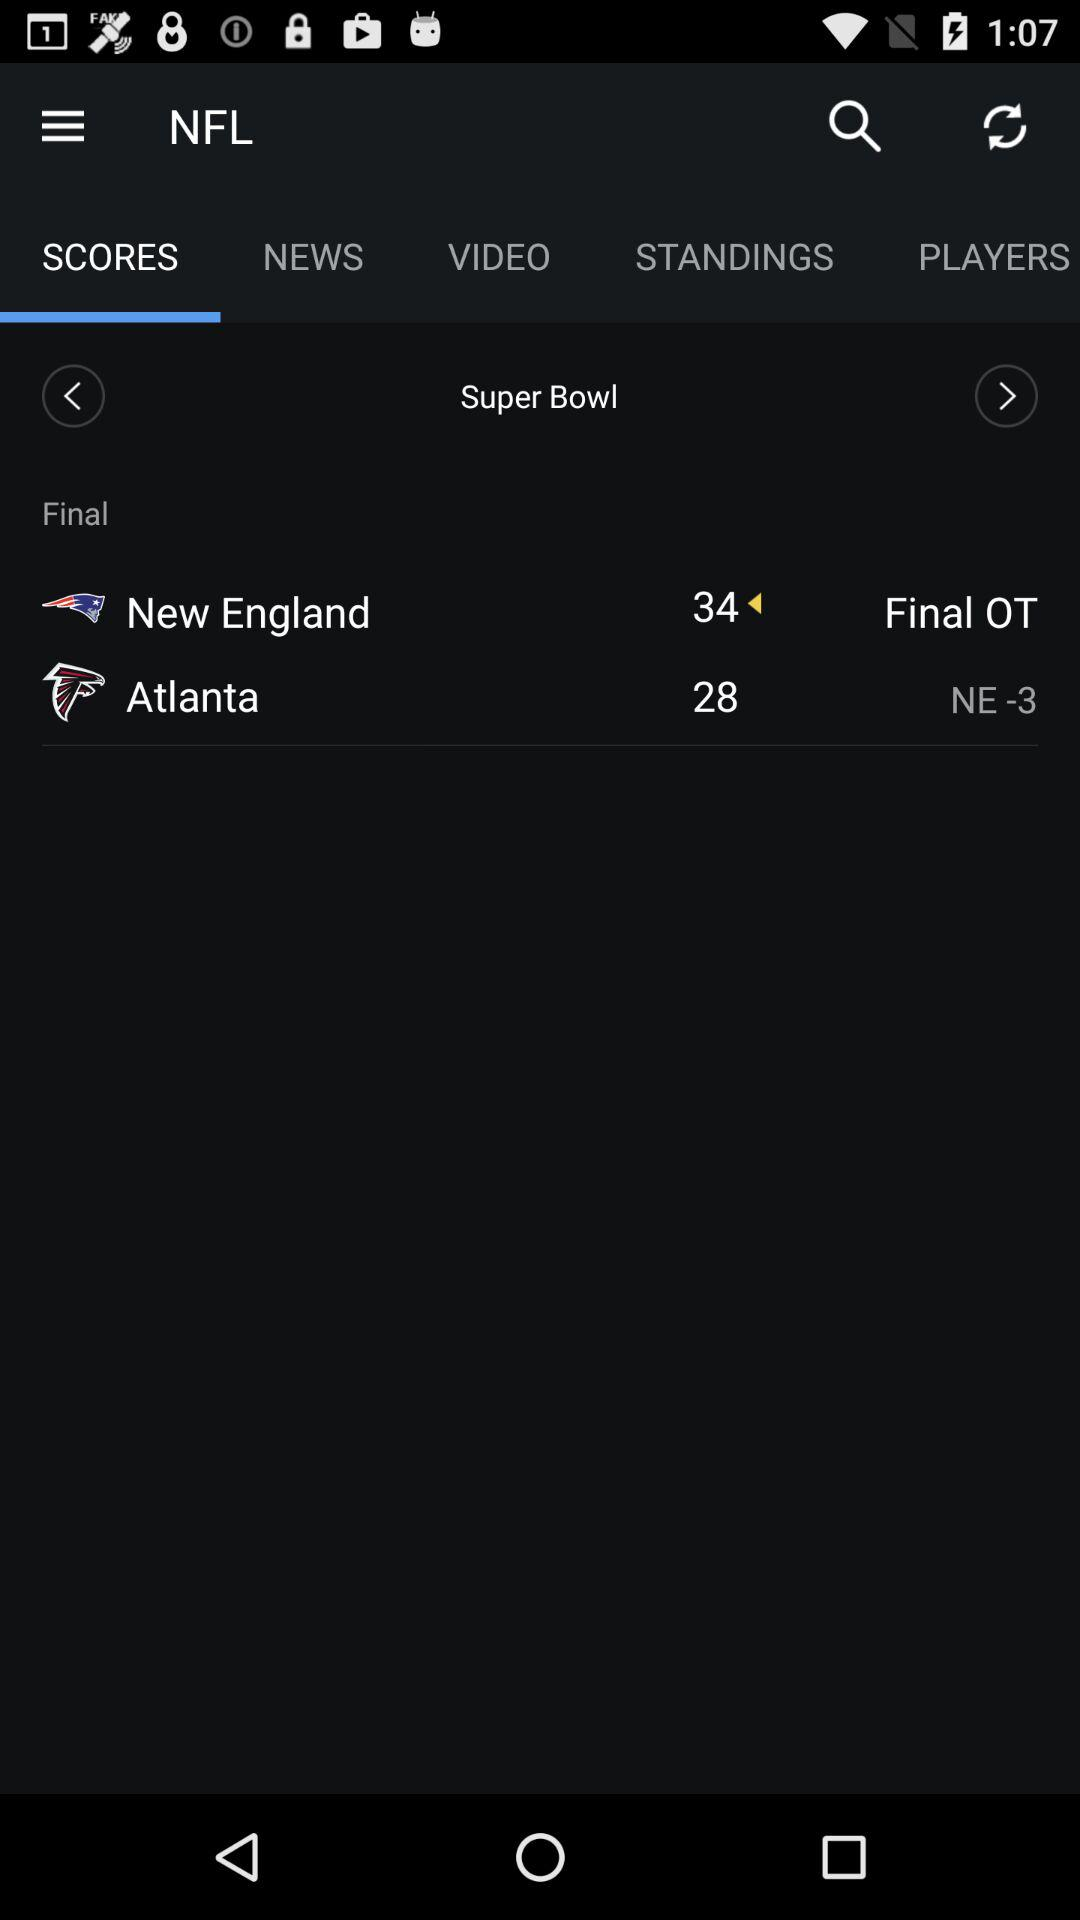Which tab is selected? The selected tab is "SCORES". 